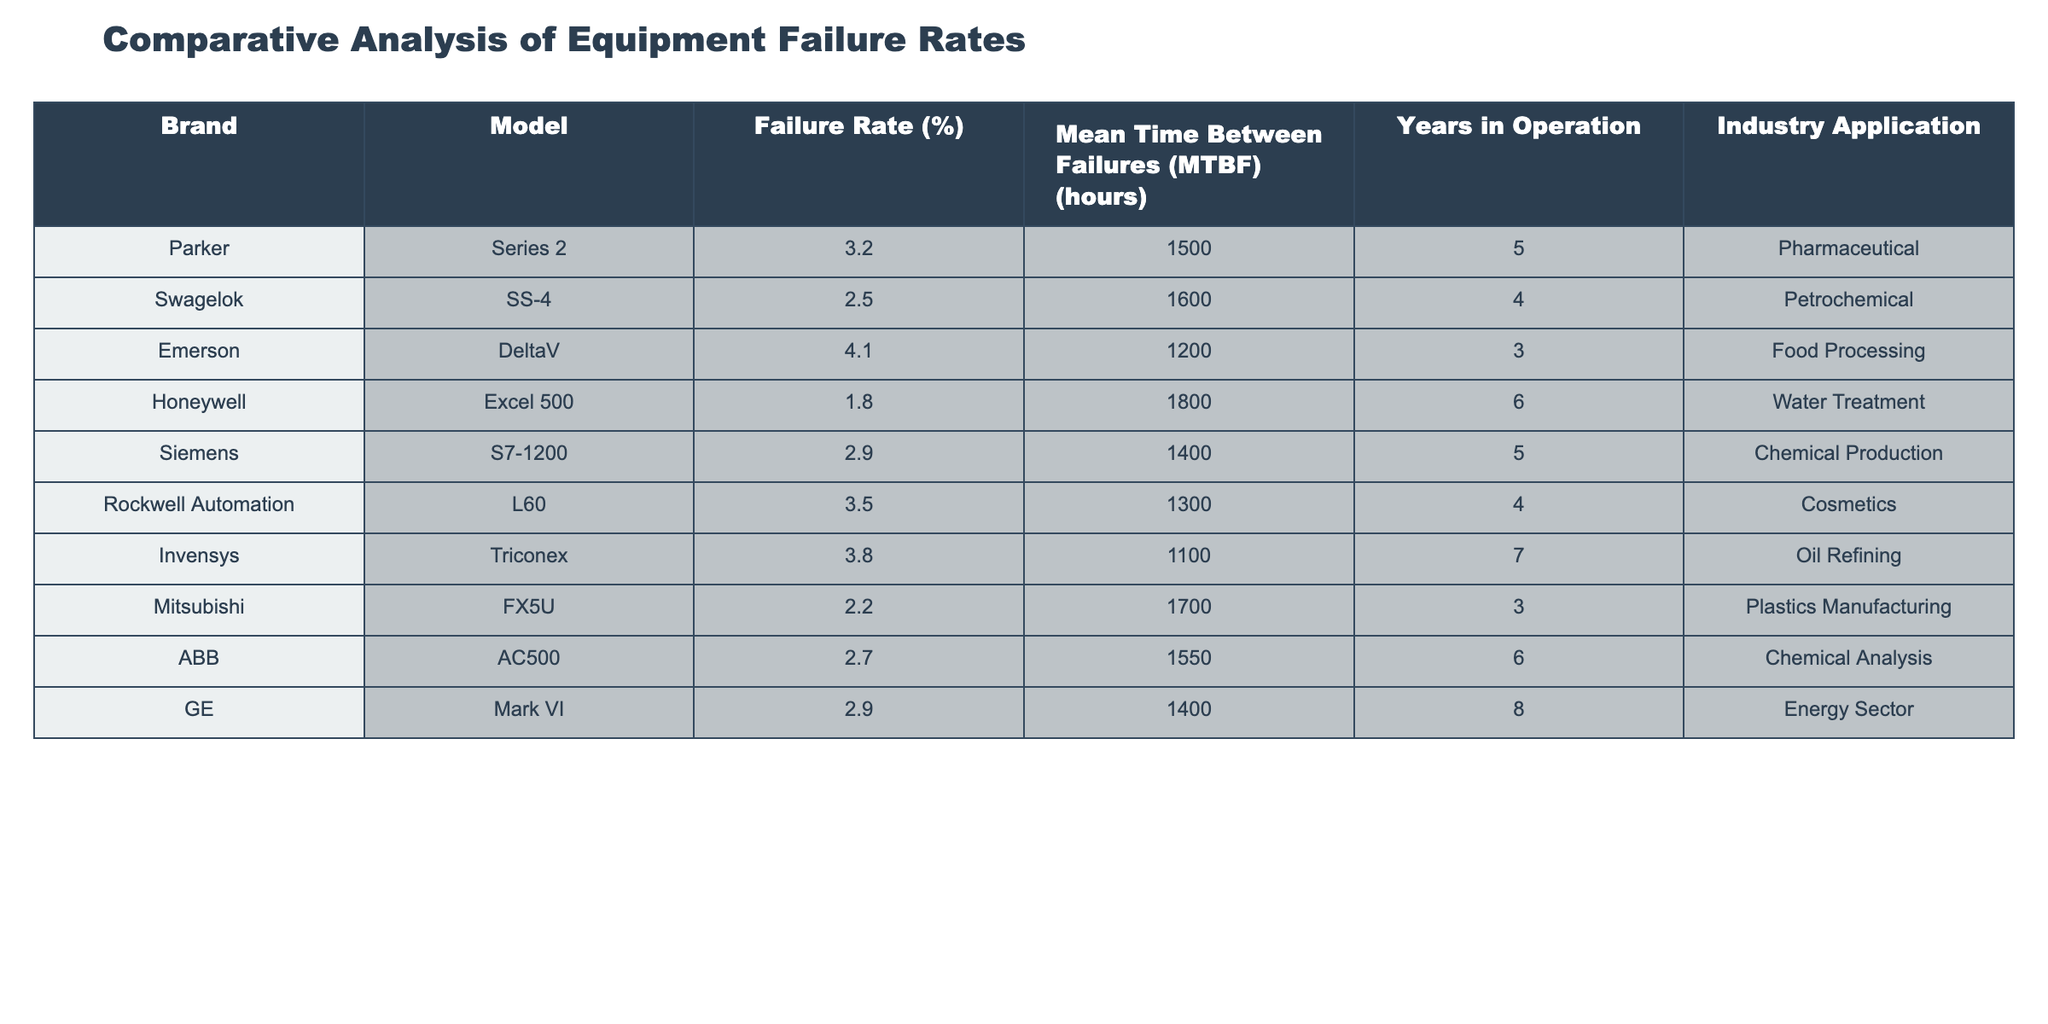What is the failure rate of Honeywell's Excel 500 model? The table lists Honeywell's Excel 500 model under the "Brand" column with an associated failure rate in the "Failure Rate (%)" column. According to the table, the failure rate is 1.8%.
Answer: 1.8% Which equipment has the highest mean time between failures (MTBF)? By examining the "Mean Time Between Failures (MTBF) (hours)" column, we can see that the Honeywell model has the highest MTBF of 1800 hours.
Answer: Honeywell, Excel 500 Are there more than two models from the Parker brand? The table only lists one model from the Parker brand, which is the Series 2. Therefore, the statement is false.
Answer: No What is the average failure rate of the equipment from brands with over 5 years in operation? The relevant brands with over 5 years in operation are Honeywell, ABB, and GE. Their failure rates are 1.8%, 2.7%, and 2.9%, respectively. Summing these gives 1.8 + 2.7 + 2.9 = 7.4%. There are three models, so the average is 7.4% / 3 = 2.47%.
Answer: 2.47% Which brand has a lower failure rate: Swagelok or Siemens? The table shows Swagelok's failure rate as 2.5% and Siemens' failure rate as 2.9%. Since 2.5% is less than 2.9%, Swagelok has the lower failure rate.
Answer: Swagelok What is the difference in failure rates between Emerson's DeltaV and Invensys' Triconex models? Emerson's DeltaV has a failure rate of 4.1%, and Invensys' Triconex has a failure rate of 3.8%. The difference is calculated as 4.1% - 3.8% = 0.3%.
Answer: 0.3% Is the average MTBF of equipment in the food processing industry greater than 1400 hours? The table has only one entry for food processing equipment, which is Emerson's DeltaV with an MTBF of 1200 hours. Since 1200 hours is not greater than 1400 hours, the statement is false.
Answer: No Which brand has the longest operational history among the listed models? Looking at the "Years in Operation" column, Invensys' Triconex has the longest operational history at 7 years.
Answer: Invensys If a new model was introduced with a failure rate of 2.0%, which brand could this model belong to given the table data? The failure rate of 2.0% is not greater than the failure rates of Swagelok (2.5%), Siemens (2.9%), and others listed. Given the comparative rates, it could belong to Mitsubishi (currently at 2.2%) if rounded down, hence indicating a possible new model.
Answer: Mitsubishi 